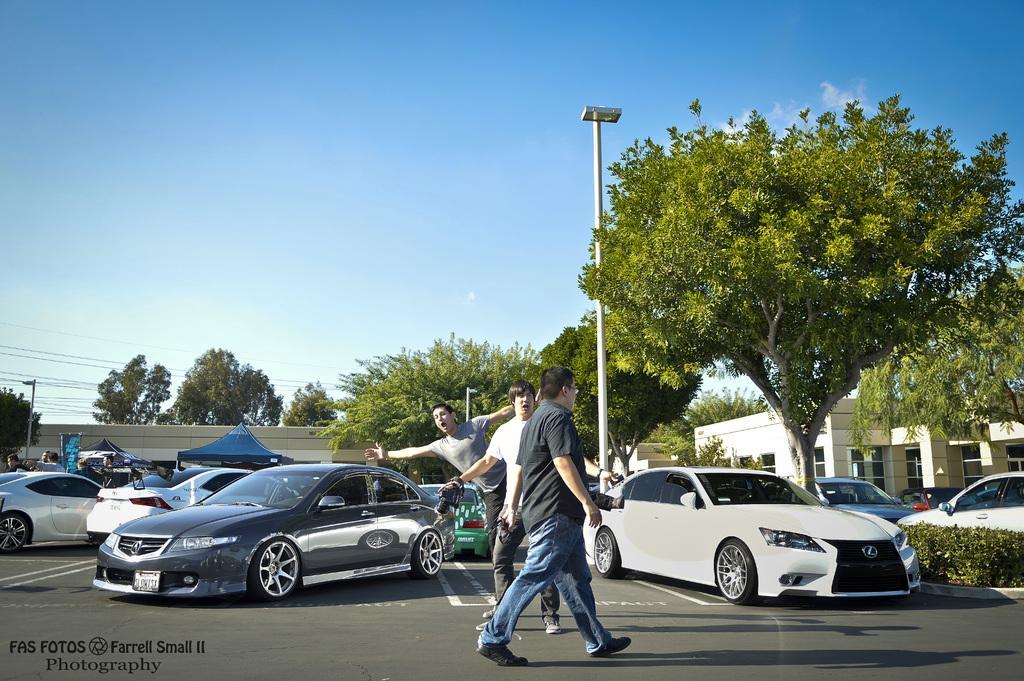Could you give a brief overview of what you see in this image? In this image I can see some people on the road behind that there are some cars, trees and buildings. 